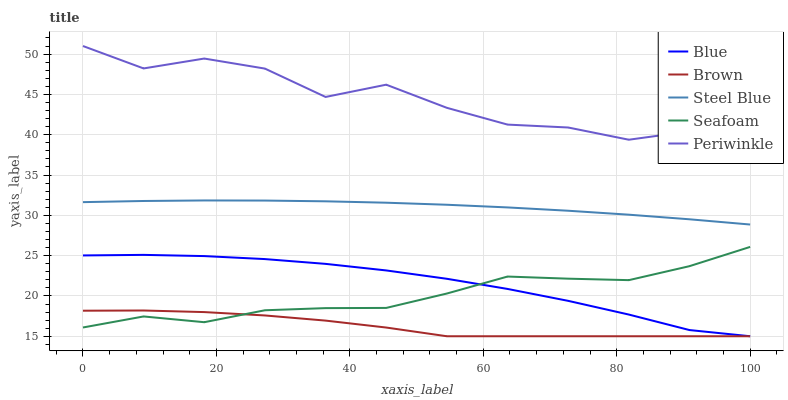Does Brown have the minimum area under the curve?
Answer yes or no. Yes. Does Periwinkle have the maximum area under the curve?
Answer yes or no. Yes. Does Periwinkle have the minimum area under the curve?
Answer yes or no. No. Does Brown have the maximum area under the curve?
Answer yes or no. No. Is Steel Blue the smoothest?
Answer yes or no. Yes. Is Periwinkle the roughest?
Answer yes or no. Yes. Is Brown the smoothest?
Answer yes or no. No. Is Brown the roughest?
Answer yes or no. No. Does Blue have the lowest value?
Answer yes or no. Yes. Does Periwinkle have the lowest value?
Answer yes or no. No. Does Periwinkle have the highest value?
Answer yes or no. Yes. Does Brown have the highest value?
Answer yes or no. No. Is Brown less than Steel Blue?
Answer yes or no. Yes. Is Periwinkle greater than Brown?
Answer yes or no. Yes. Does Seafoam intersect Blue?
Answer yes or no. Yes. Is Seafoam less than Blue?
Answer yes or no. No. Is Seafoam greater than Blue?
Answer yes or no. No. Does Brown intersect Steel Blue?
Answer yes or no. No. 